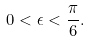Convert formula to latex. <formula><loc_0><loc_0><loc_500><loc_500>0 < \epsilon < \frac { \pi } { 6 } .</formula> 